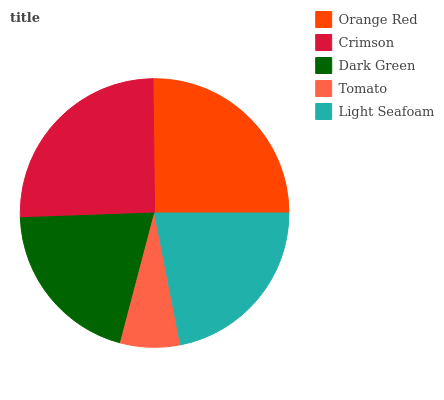Is Tomato the minimum?
Answer yes or no. Yes. Is Crimson the maximum?
Answer yes or no. Yes. Is Dark Green the minimum?
Answer yes or no. No. Is Dark Green the maximum?
Answer yes or no. No. Is Crimson greater than Dark Green?
Answer yes or no. Yes. Is Dark Green less than Crimson?
Answer yes or no. Yes. Is Dark Green greater than Crimson?
Answer yes or no. No. Is Crimson less than Dark Green?
Answer yes or no. No. Is Light Seafoam the high median?
Answer yes or no. Yes. Is Light Seafoam the low median?
Answer yes or no. Yes. Is Crimson the high median?
Answer yes or no. No. Is Orange Red the low median?
Answer yes or no. No. 